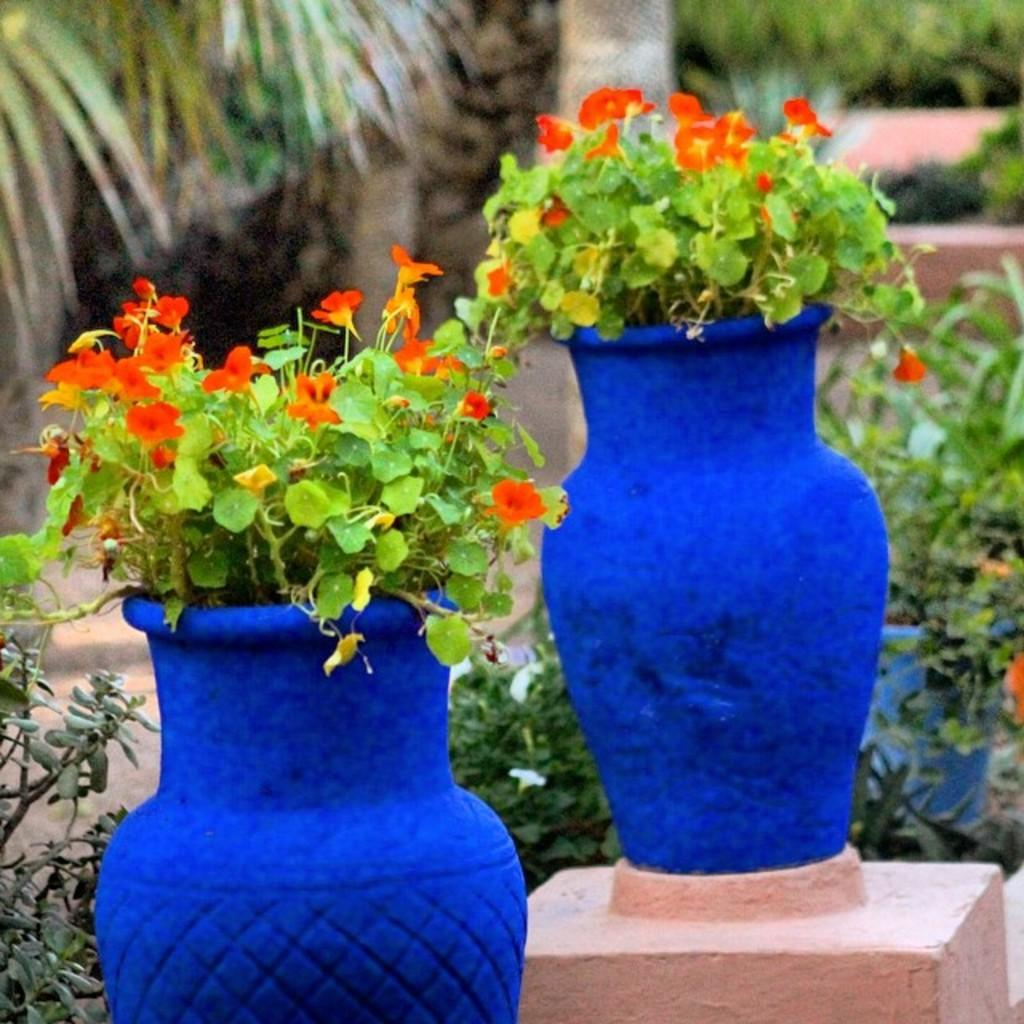What type of vegetation can be seen in the image? There are plants in the image. What is located behind the plants in the image? There are trees behind the plants in the image. What type of cord is being used by the creature in the image? There is no creature or cord present in the image. What kind of arch can be seen in the background of the image? There is no arch present in the image; it only features plants and trees. 